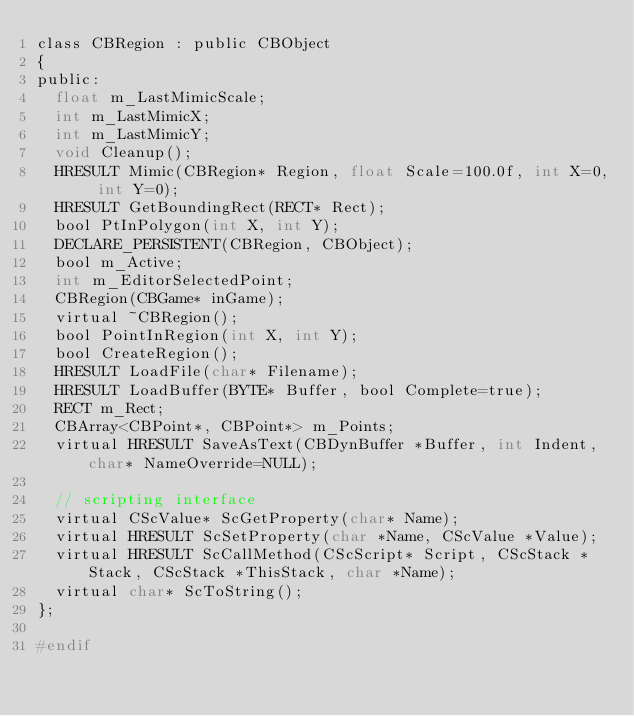Convert code to text. <code><loc_0><loc_0><loc_500><loc_500><_C_>class CBRegion : public CBObject
{
public:
	float m_LastMimicScale;
	int m_LastMimicX;
	int m_LastMimicY;
	void Cleanup();
	HRESULT Mimic(CBRegion* Region, float Scale=100.0f, int X=0, int Y=0);
	HRESULT GetBoundingRect(RECT* Rect);
	bool PtInPolygon(int X, int Y);
	DECLARE_PERSISTENT(CBRegion, CBObject);
	bool m_Active;
	int m_EditorSelectedPoint;
	CBRegion(CBGame* inGame);
	virtual ~CBRegion();
	bool PointInRegion(int X, int Y);
	bool CreateRegion();
	HRESULT LoadFile(char* Filename);
	HRESULT LoadBuffer(BYTE* Buffer, bool Complete=true);
	RECT m_Rect;
	CBArray<CBPoint*, CBPoint*> m_Points;
	virtual HRESULT SaveAsText(CBDynBuffer *Buffer, int Indent, char* NameOverride=NULL);

	// scripting interface
	virtual CScValue* ScGetProperty(char* Name);
	virtual HRESULT ScSetProperty(char *Name, CScValue *Value);
	virtual HRESULT ScCallMethod(CScScript* Script, CScStack *Stack, CScStack *ThisStack, char *Name);
	virtual char* ScToString();
};

#endif
</code> 